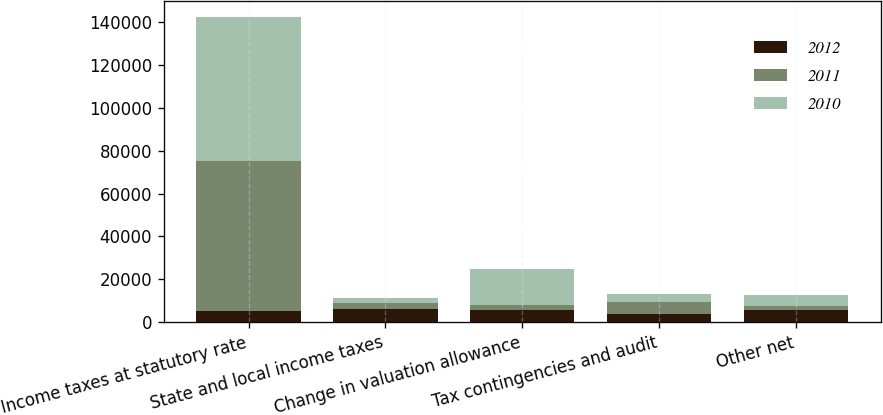Convert chart. <chart><loc_0><loc_0><loc_500><loc_500><stacked_bar_chart><ecel><fcel>Income taxes at statutory rate<fcel>State and local income taxes<fcel>Change in valuation allowance<fcel>Tax contingencies and audit<fcel>Other net<nl><fcel>2012<fcel>5285<fcel>6004<fcel>5703<fcel>3598<fcel>5456<nl><fcel>2011<fcel>69956<fcel>2821<fcel>2052<fcel>5911<fcel>1947<nl><fcel>2010<fcel>67427<fcel>2358<fcel>17139<fcel>3447<fcel>5114<nl></chart> 